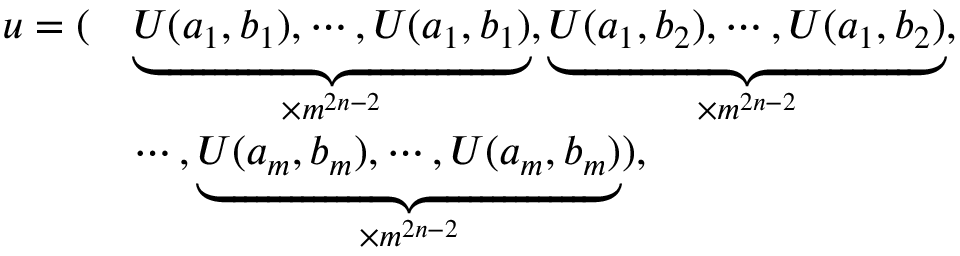<formula> <loc_0><loc_0><loc_500><loc_500>\begin{array} { r l } { u = ( } & { \underbrace { U ( a _ { 1 } , b _ { 1 } ) , \cdots , U ( a _ { 1 } , b _ { 1 } ) } _ { \times m ^ { 2 n - 2 } } , \underbrace { U ( a _ { 1 } , b _ { 2 } ) , \cdots , U ( a _ { 1 } , b _ { 2 } ) } _ { \times m ^ { 2 n - 2 } } , } \\ & { \cdots , \underbrace { U ( a _ { m } , b _ { m } ) , \cdots , U ( a _ { m } , b _ { m } ) } _ { \times m ^ { 2 n - 2 } } ) , } \end{array}</formula> 